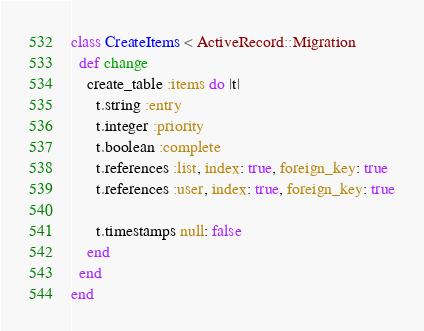Convert code to text. <code><loc_0><loc_0><loc_500><loc_500><_Ruby_>class CreateItems < ActiveRecord::Migration
  def change
    create_table :items do |t|
      t.string :entry
      t.integer :priority
      t.boolean :complete
      t.references :list, index: true, foreign_key: true
      t.references :user, index: true, foreign_key: true

      t.timestamps null: false
    end
  end
end
</code> 